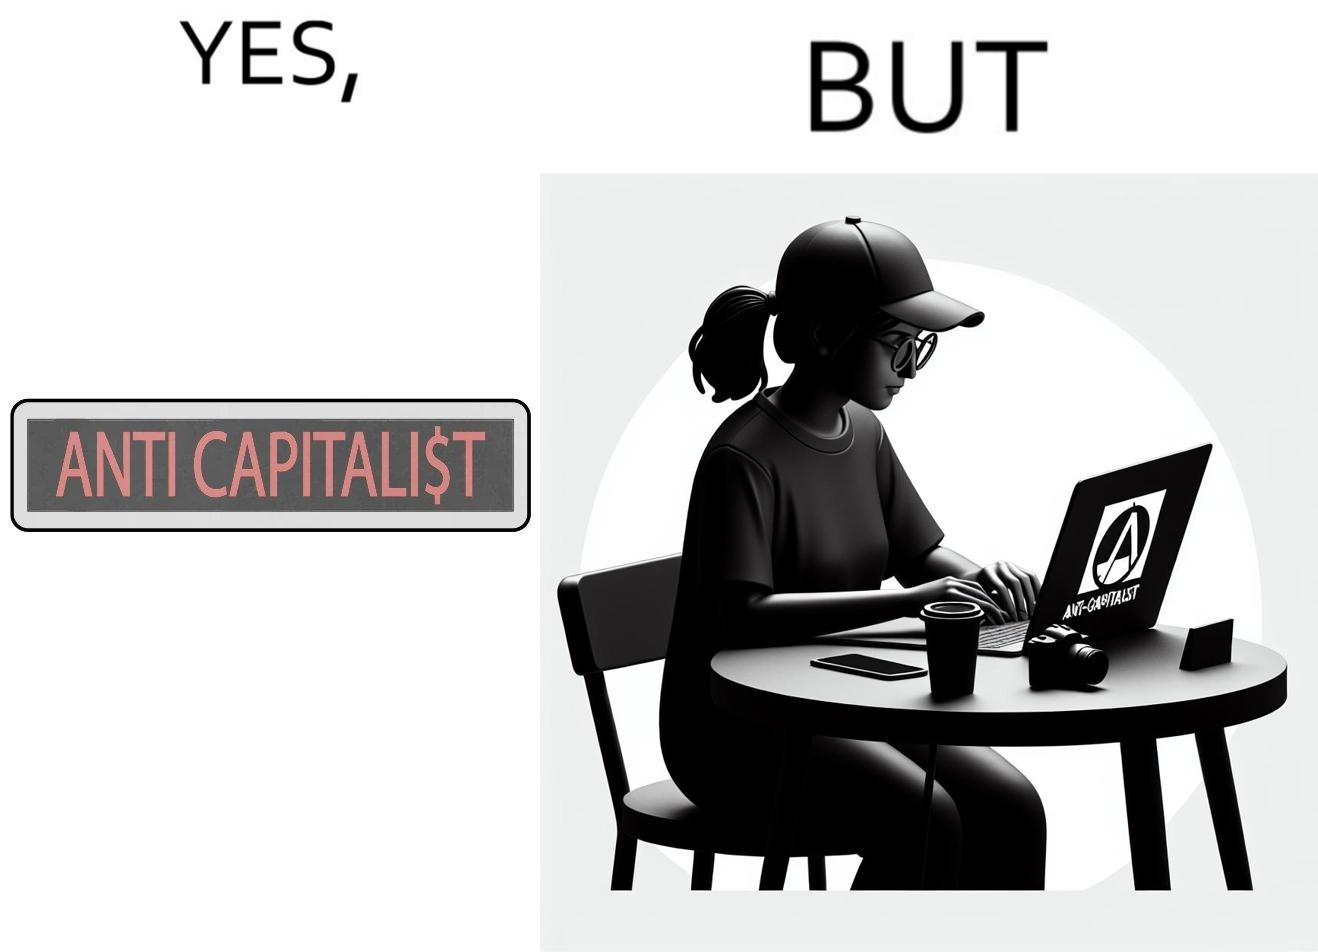Is there satirical content in this image? Yes, this image is satirical. 